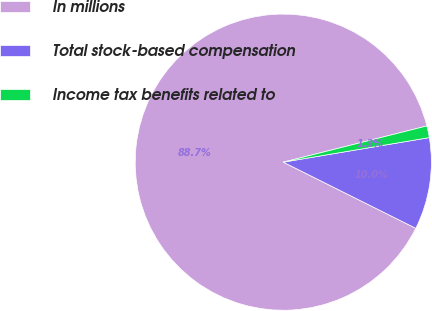<chart> <loc_0><loc_0><loc_500><loc_500><pie_chart><fcel>In millions<fcel>Total stock-based compensation<fcel>Income tax benefits related to<nl><fcel>88.7%<fcel>10.02%<fcel>1.28%<nl></chart> 